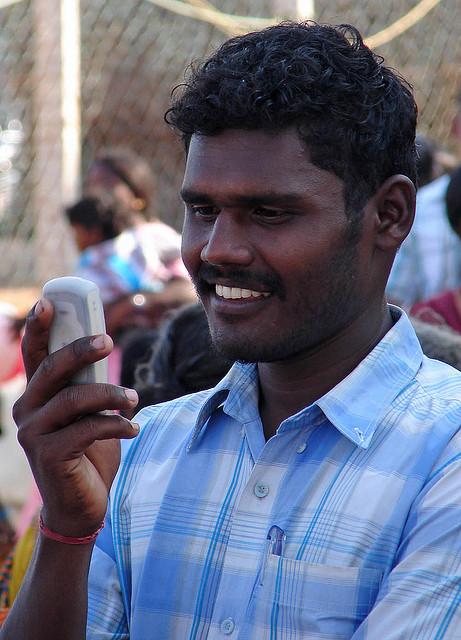What region is this man probably from?
Quick response, please. India. Is the man interacting with a bar of soap or a mobile device?
Give a very brief answer. Mobile device. What pattern is the man's shirt?
Concise answer only. Plaid. 